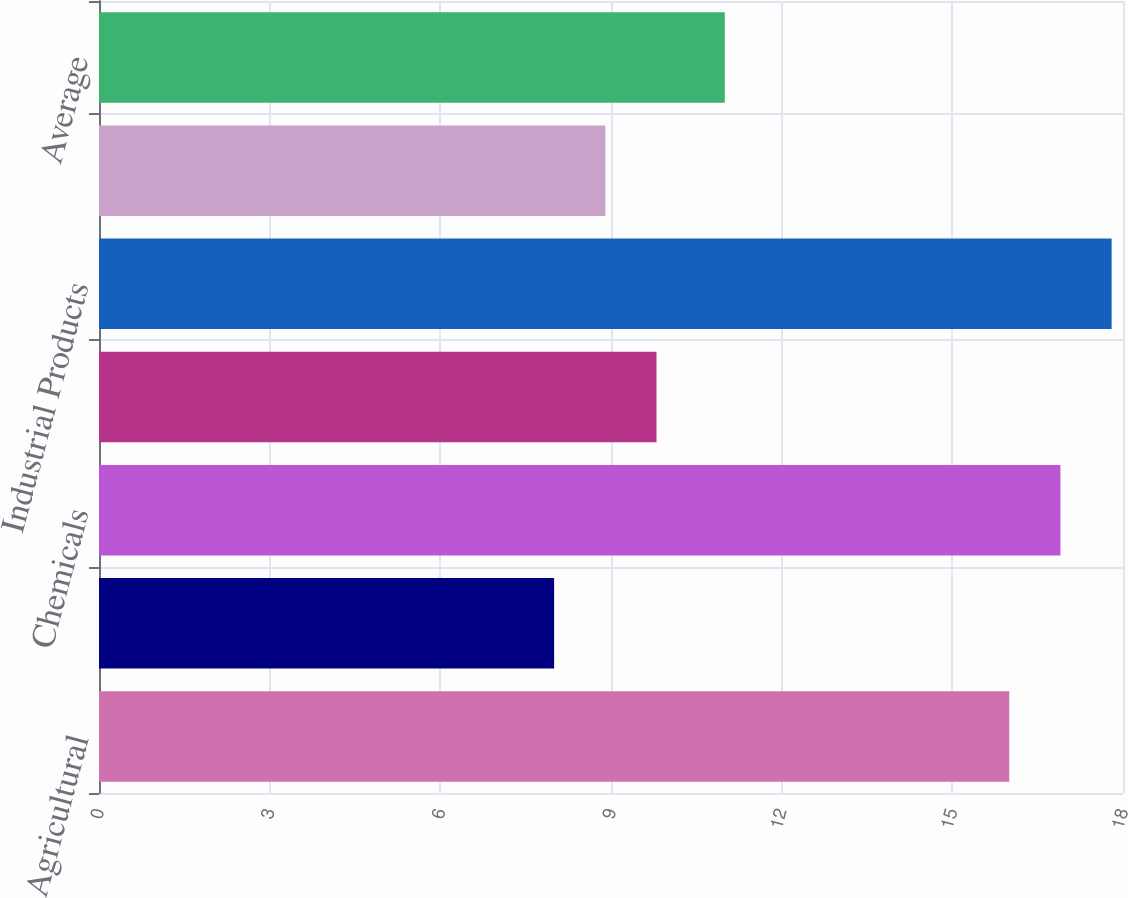Convert chart to OTSL. <chart><loc_0><loc_0><loc_500><loc_500><bar_chart><fcel>Agricultural<fcel>Automotive<fcel>Chemicals<fcel>Energy<fcel>Industrial Products<fcel>Intermodal<fcel>Average<nl><fcel>16<fcel>8<fcel>16.9<fcel>9.8<fcel>17.8<fcel>8.9<fcel>11<nl></chart> 